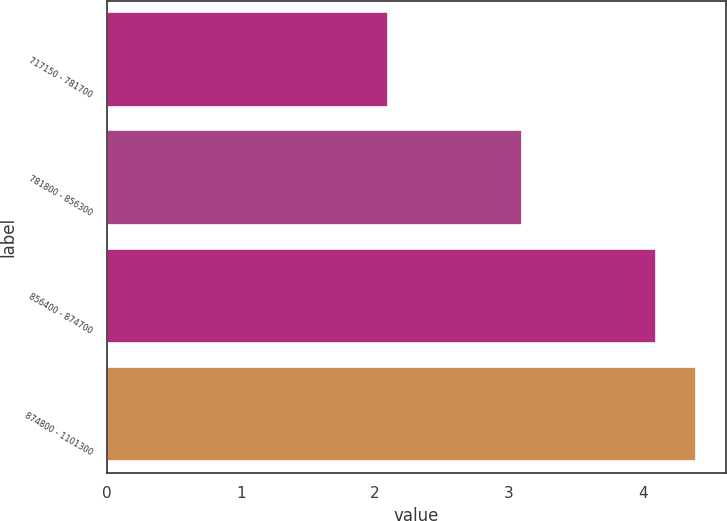Convert chart to OTSL. <chart><loc_0><loc_0><loc_500><loc_500><bar_chart><fcel>717150 - 781700<fcel>781800 - 856300<fcel>856400 - 874700<fcel>874800 - 1101300<nl><fcel>2.1<fcel>3.1<fcel>4.1<fcel>4.4<nl></chart> 